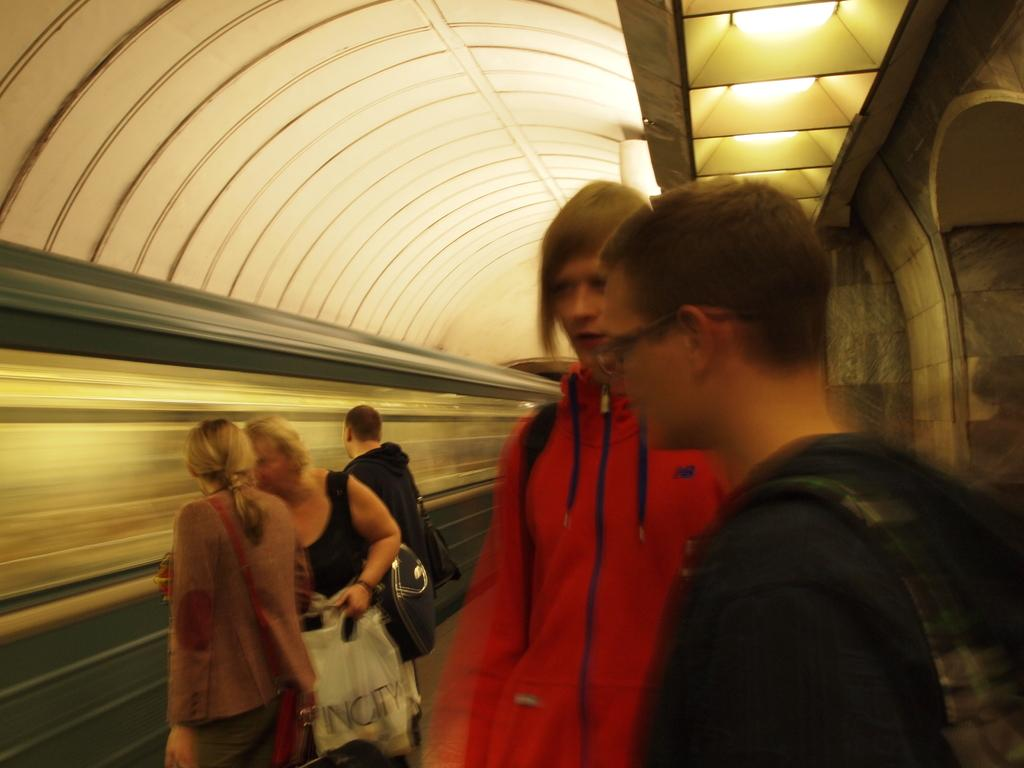What are the people in the image doing? The persons are standing on a platform in the image. What is the main mode of transportation in the image? There is a train in the image. Is the train stationary or moving? The train is moving in the image. What is the structure above the platform? There is a roof visible in the image. What can be seen providing illumination in the image? There are lights present in the image. What type of bucket is being used for a game of chess in the image? There is no bucket or game of chess present in the image. How long does it take for the train to pass through the image? The provided facts do not mention the duration of the train's movement, so it cannot be determined from the image. 